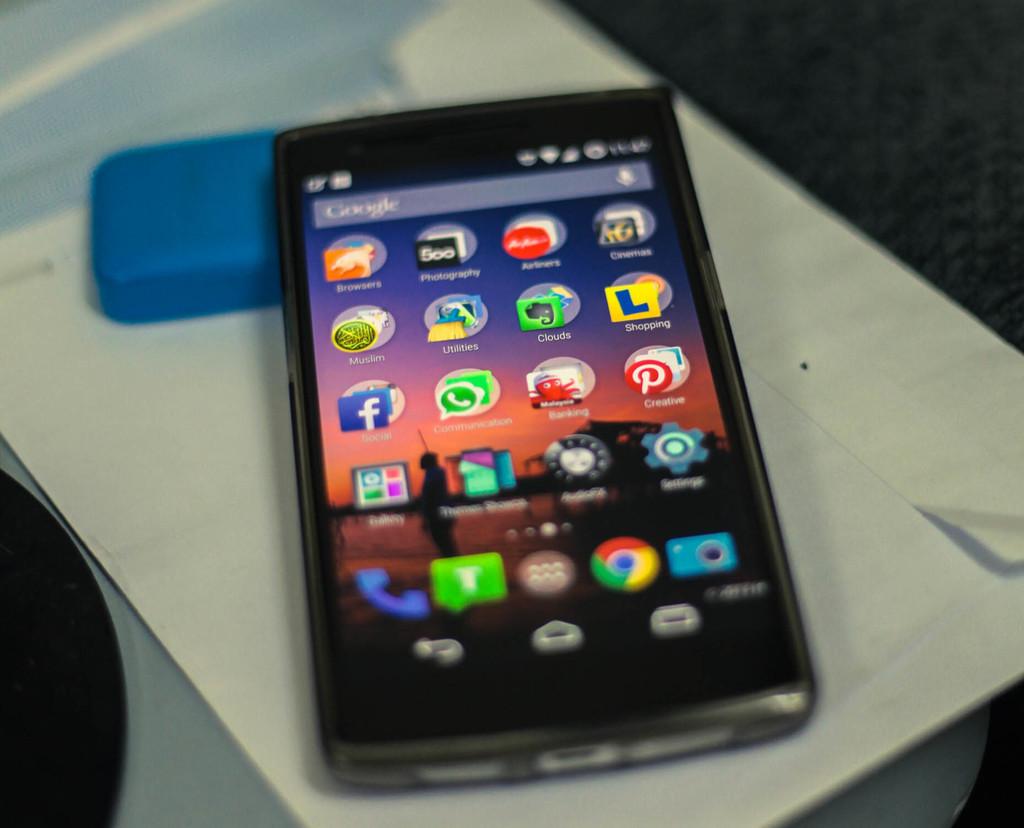Is the search engine on the phone google or bing?
Your answer should be compact. Google. 